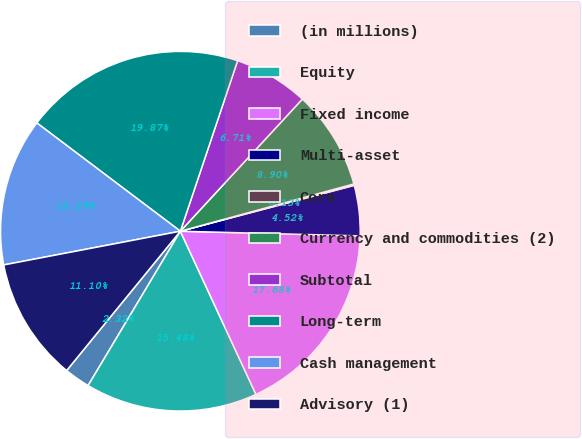Convert chart. <chart><loc_0><loc_0><loc_500><loc_500><pie_chart><fcel>(in millions)<fcel>Equity<fcel>Fixed income<fcel>Multi-asset<fcel>Core<fcel>Currency and commodities (2)<fcel>Subtotal<fcel>Long-term<fcel>Cash management<fcel>Advisory (1)<nl><fcel>2.32%<fcel>15.48%<fcel>17.68%<fcel>4.52%<fcel>0.13%<fcel>8.9%<fcel>6.71%<fcel>19.87%<fcel>13.29%<fcel>11.1%<nl></chart> 